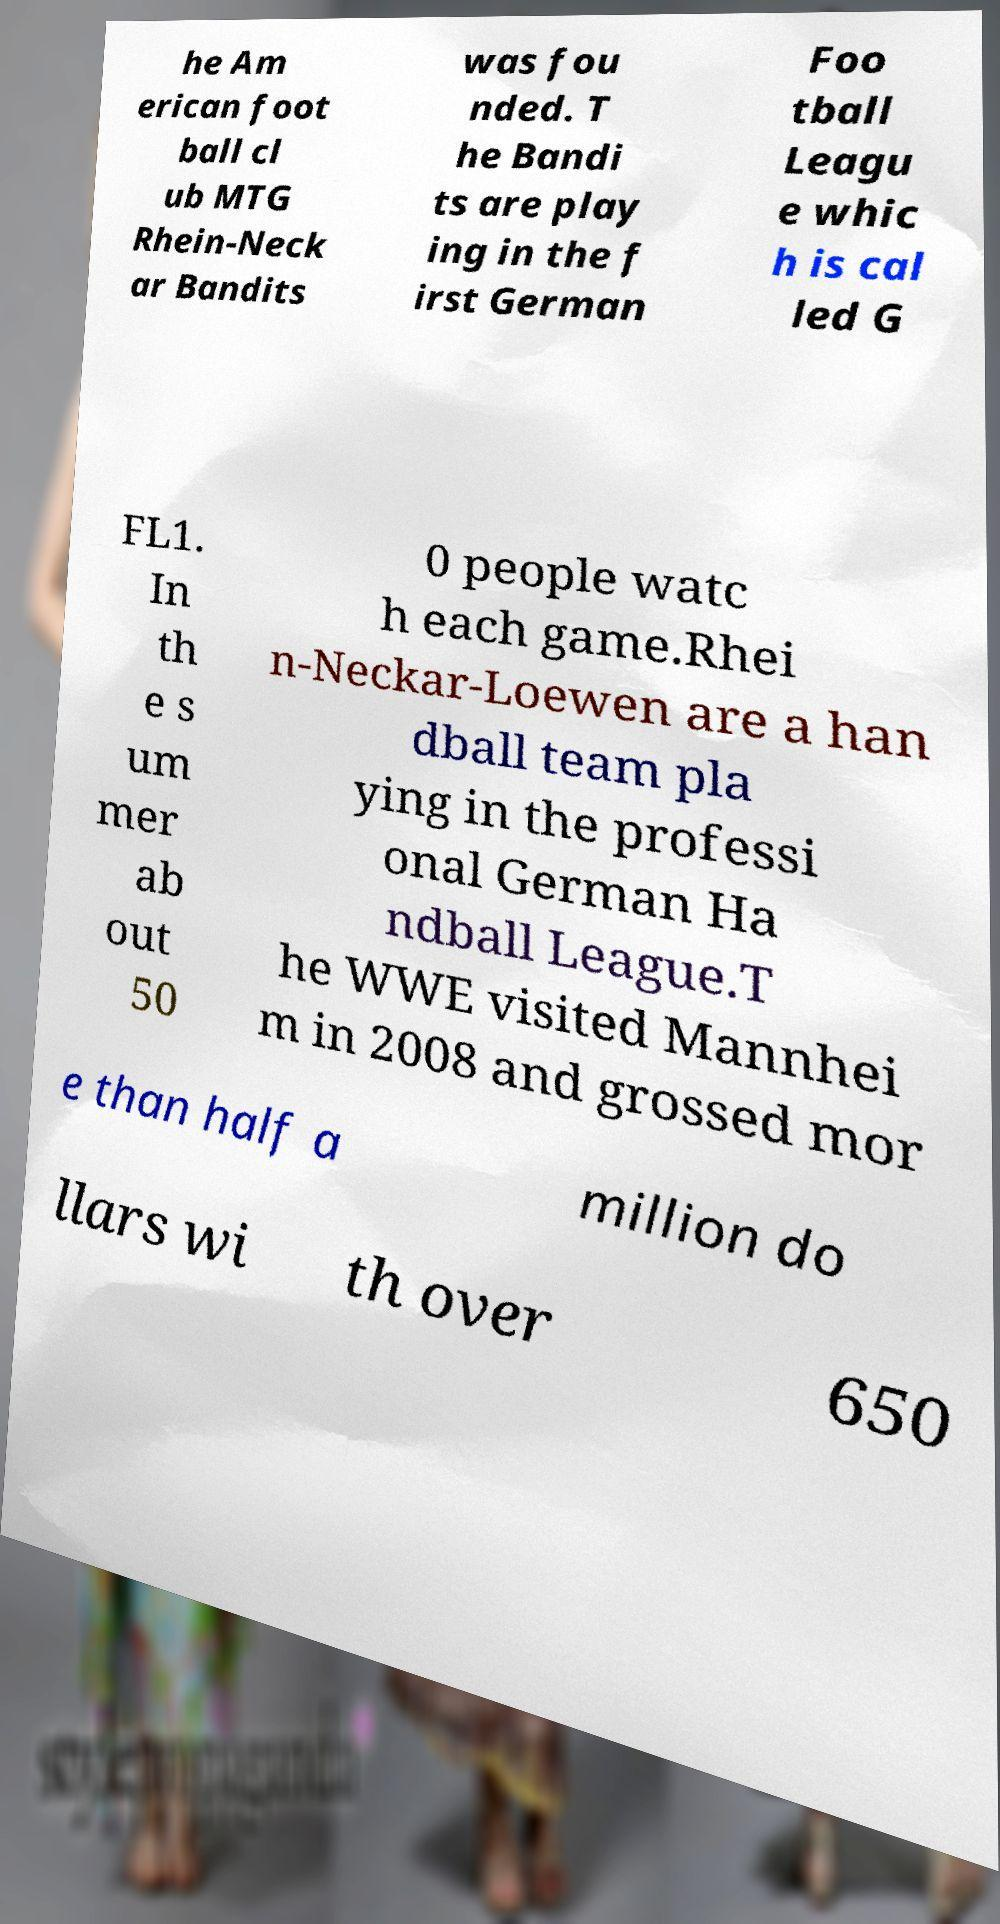Please read and relay the text visible in this image. What does it say? he Am erican foot ball cl ub MTG Rhein-Neck ar Bandits was fou nded. T he Bandi ts are play ing in the f irst German Foo tball Leagu e whic h is cal led G FL1. In th e s um mer ab out 50 0 people watc h each game.Rhei n-Neckar-Loewen are a han dball team pla ying in the professi onal German Ha ndball League.T he WWE visited Mannhei m in 2008 and grossed mor e than half a million do llars wi th over 650 